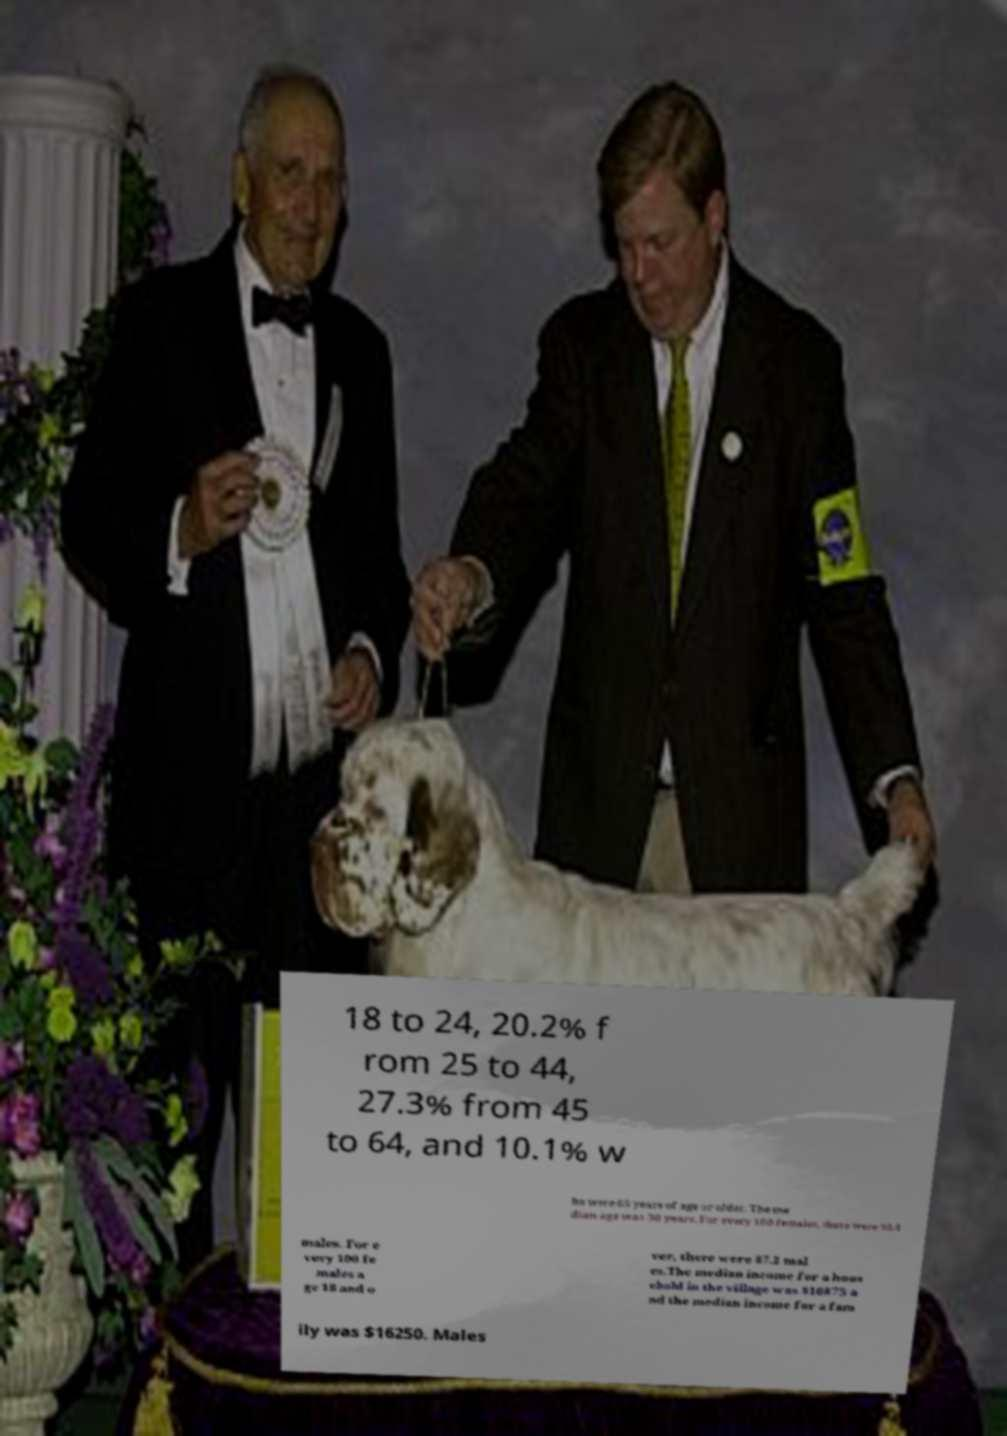What messages or text are displayed in this image? I need them in a readable, typed format. 18 to 24, 20.2% f rom 25 to 44, 27.3% from 45 to 64, and 10.1% w ho were 65 years of age or older. The me dian age was 30 years. For every 100 females, there were 90.4 males. For e very 100 fe males a ge 18 and o ver, there were 87.2 mal es.The median income for a hous ehold in the village was $16875 a nd the median income for a fam ily was $16250. Males 